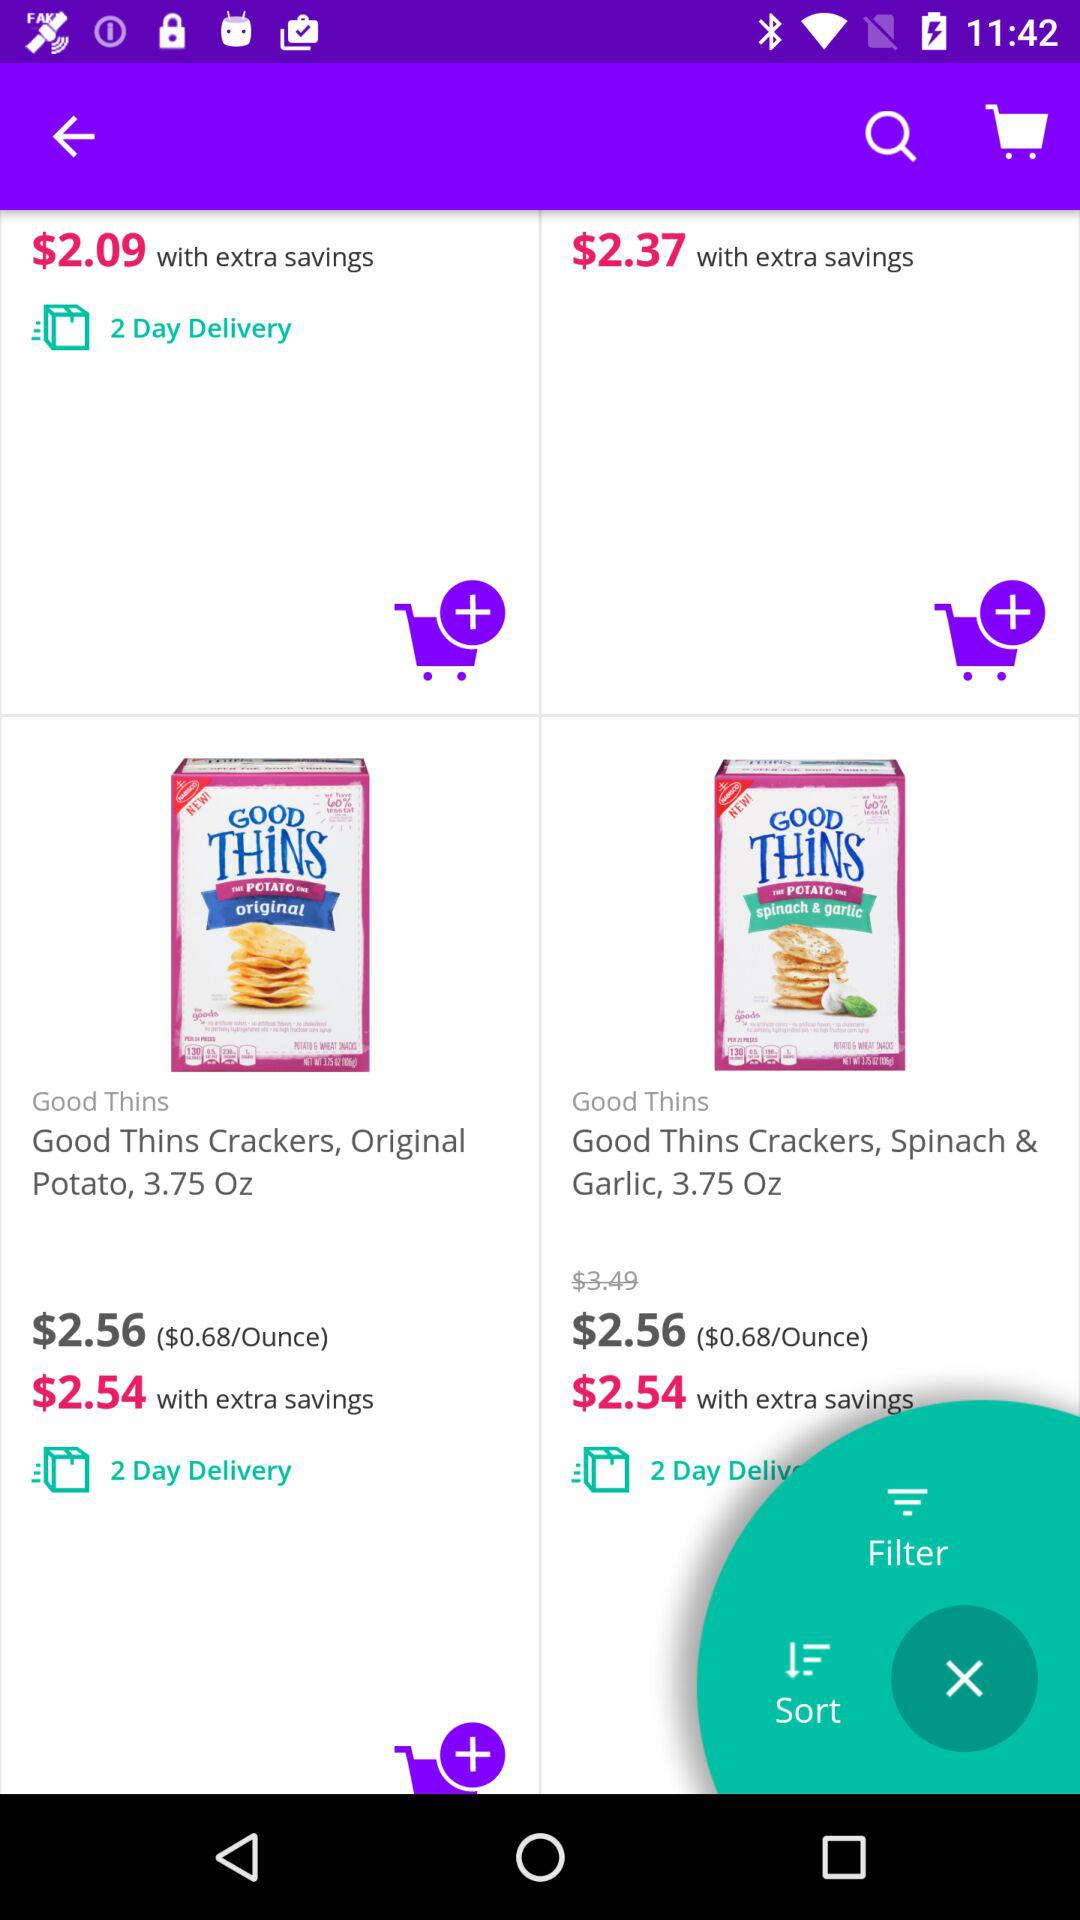What is the weight of "Good Thins Crackers, Original Potato"? The weight is 3.75 oz. 